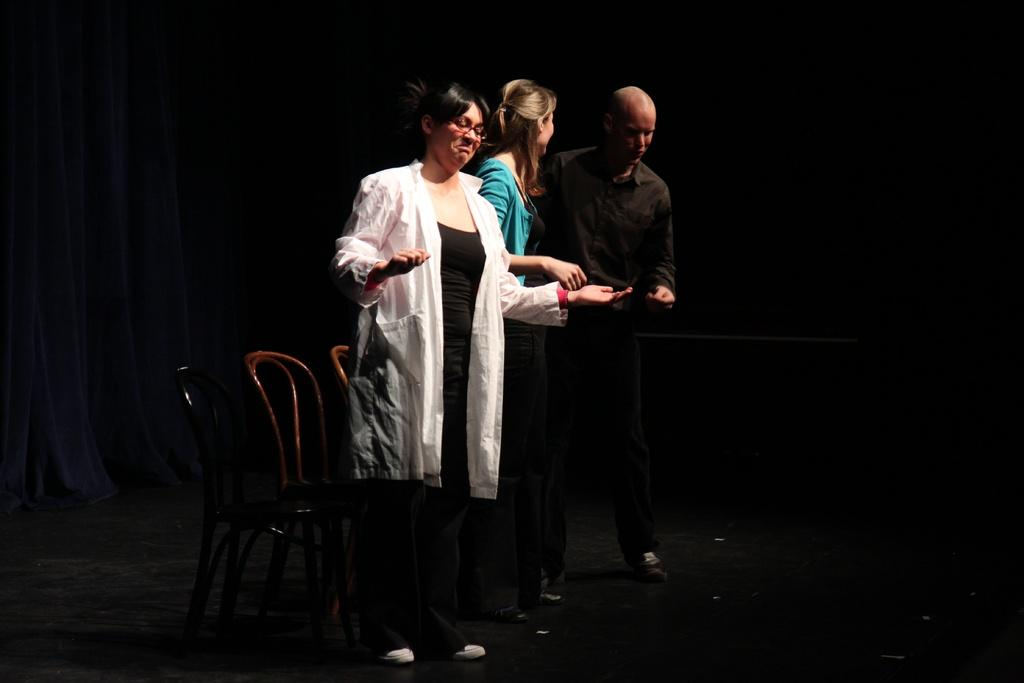What are the people in the image doing? The people in the image are standing on a stage. What objects are near the people on the stage? There are chairs beside the people on the stage. What can be seen in the background of the image? There is a curtain in the background. What type of knife is being used to cut the fog in the image? There is no knife or fog present in the image. How does the pump affect the people standing on the stage in the image? There is no pump present in the image, so it cannot affect the people on the stage. 